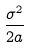<formula> <loc_0><loc_0><loc_500><loc_500>\frac { \sigma ^ { 2 } } { 2 a }</formula> 